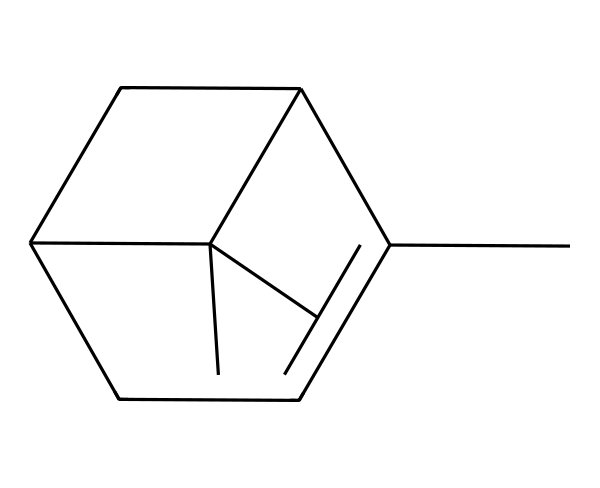How many carbon atoms are in alpha-pinene? Counting the carbon atoms in the SMILES representation, we see there are 10 carbon atoms (C).
Answer: 10 What is the molecular formula of alpha-pinene? By interpreting the structure and counting the atoms, the molecular formula is C10H16 (from 10 carbons and 16 hydrogens).
Answer: C10H16 Does alpha-pinene have any rings in its structure? The structure shows that there are two rings formed by carbon atoms, confirming it is a bicyclic structure.
Answer: Yes What type of functional groups are present in alpha-pinene? The structure corresponds to a terpene that primarily features alkene groups due to the double bonds, but there are no other functional groups visible.
Answer: Alkene What is the overall geometry around the double bonds in alpha-pinene? The presence of double bonds indicates that the geometry around those carbons is trigonal planar due to sp2 hybridization.
Answer: Trigonal planar Is alpha-pinene chiral? Analyzing the structure indicates that there are stereocenters present (carbons bonded to four different substituents), thus making the molecule chiral.
Answer: Yes What is the significance of the bicyclic structure in alpha-pinene? The bicyclic structure contributes to the stability and unique physical properties of terpene compounds, affecting their reactivity and interactions.
Answer: Stability and reactivity 